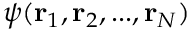Convert formula to latex. <formula><loc_0><loc_0><loc_500><loc_500>\psi ( r _ { 1 } , r _ { 2 } , \dots , r _ { N } )</formula> 